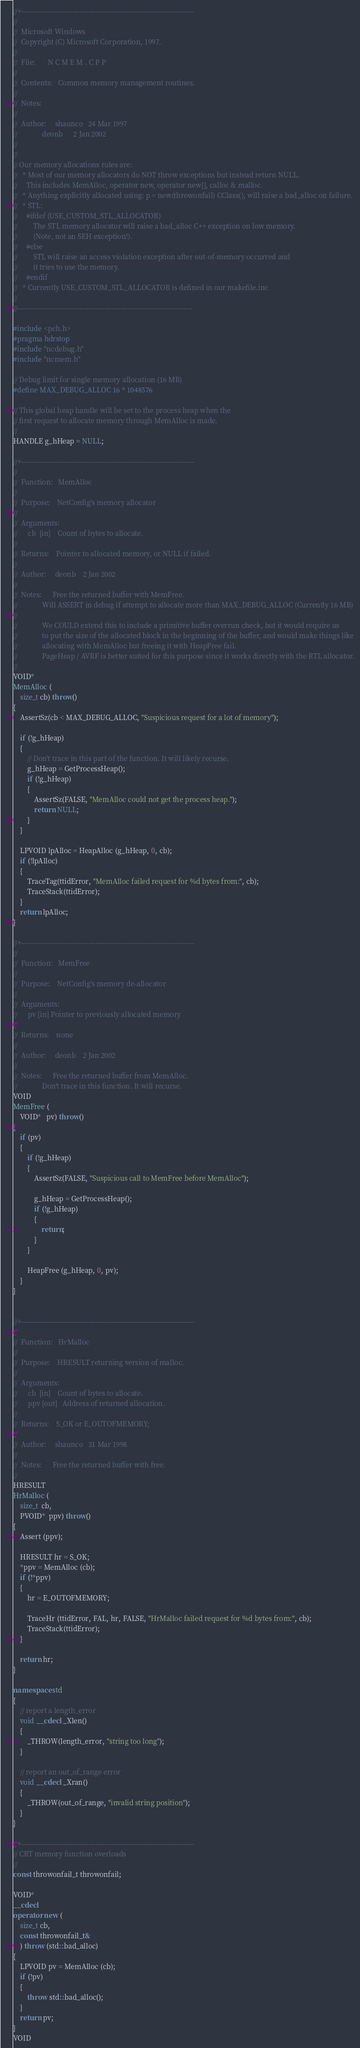Convert code to text. <code><loc_0><loc_0><loc_500><loc_500><_C++_>//+---------------------------------------------------------------------------
//
//  Microsoft Windows
//  Copyright (C) Microsoft Corporation, 1997.
//
//  File:       N C M E M . C P P
//
//  Contents:   Common memory management routines.
//
//  Notes:
//
//  Author:     shaunco   24 Mar 1997
//              deonb      2 Jan 2002
//
//
// Our memory allocations rules are:
//   * Most of our memory allocators do NOT throw exceptions but instead return NULL. 
//     This includes MemAlloc, operator new, operator new[], calloc & malloc.
//   * Anything explicitly allocated using: p = new(throwonfail) CClass(), will raise a bad_alloc on failure.
//   * STL:
//     #ifdef (USE_CUSTOM_STL_ALLOCATOR)
//         The STL memory allocator will raise a bad_alloc C++ exception on low memory.
//         (Note, not an SEH exception!). 
//     #else
//         STL will raise an access violation exception after out-of-memory occurred and
//         it tries to use the memory.
//     #endif
//   * Currently USE_CUSTOM_STL_ALLOCATOR is defined in our makefile.inc
// 
//----------------------------------------------------------------------------

#include <pch.h>
#pragma hdrstop
#include "ncdebug.h"
#include "ncmem.h"

// Debug limit for single memory allocation (16 MB)
#define MAX_DEBUG_ALLOC 16 * 1048576

// This global heap handle will be set to the process heap when the
// first request to allocate memory through MemAlloc is made.
//
HANDLE g_hHeap = NULL;

//+---------------------------------------------------------------------------
//
//  Function:   MemAlloc
//
//  Purpose:    NetConfig's memory allocator
//
//  Arguments:
//      cb  [in]    Count of bytes to allocate.
//
//  Returns:    Pointer to allocated memory, or NULL if failed.
//
//  Author:     deonb    2 Jan 2002
//
//  Notes:      Free the returned buffer with MemFree.
//              Will ASSERT in debug if attempt to allocate more than MAX_DEBUG_ALLOC (Currently 16 MB)
//
//              We COULD extend this to include a primitive buffer overrun check, but it would require us
//              to put the size of the allocated block in the beginning of the buffer, and would make things like
//              allocating with MemAlloc but freeing it with HeapFree fail. 
//              PageHeap / AVRF is better suited for this purpose since it works directly with the RTL allocator.
//
VOID*
MemAlloc (
    size_t cb) throw()
{
    AssertSz(cb < MAX_DEBUG_ALLOC, "Suspicious request for a lot of memory"); 

    if (!g_hHeap)
    {
        // Don't trace in this part of the function. It will likely recurse.
        g_hHeap = GetProcessHeap();
        if (!g_hHeap)
        {
            AssertSz(FALSE, "MemAlloc could not get the process heap.");
            return NULL;
        }
    }

    LPVOID lpAlloc = HeapAlloc (g_hHeap, 0, cb);
    if (!lpAlloc)
    {
        TraceTag(ttidError, "MemAlloc failed request for %d bytes from:", cb);
        TraceStack(ttidError);
    }
    return lpAlloc;
}

//+---------------------------------------------------------------------------
//
//  Function:   MemFree
//
//  Purpose:    NetConfig's memory de-allocator
//
//  Arguments:
//      pv [in] Pointer to previously allocated memory
//
//  Returns:    none
//
//  Author:     deonb    2 Jan 2002
//
//  Notes:      Free the returned buffer from MemAlloc.
//              Don't trace in this function. It will recurse.
VOID
MemFree (
    VOID*   pv) throw()
{
    if (pv) 
    {
        if (!g_hHeap)
        {
            AssertSz(FALSE, "Suspicious call to MemFree before MemAlloc");

            g_hHeap = GetProcessHeap();
            if (!g_hHeap)
            {
                return;
            }
        }

        HeapFree (g_hHeap, 0, pv);
    }
}


//+---------------------------------------------------------------------------
//
//  Function:   HrMalloc
//
//  Purpose:    HRESULT returning version of malloc.
//
//  Arguments:
//      cb  [in]    Count of bytes to allocate.
//      ppv [out]   Address of returned allocation.
//
//  Returns:    S_OK or E_OUTOFMEMORY;
//
//  Author:     shaunco   31 Mar 1998
//
//  Notes:      Free the returned buffer with free.
//
HRESULT
HrMalloc (
    size_t  cb,
    PVOID*  ppv) throw()
{
    Assert (ppv);

    HRESULT hr = S_OK;
    *ppv = MemAlloc (cb);
    if (!*ppv)
    {
        hr = E_OUTOFMEMORY;
    
        TraceHr (ttidError, FAL, hr, FALSE, "HrMalloc failed request for %d bytes from:", cb);
        TraceStack(ttidError);
    }

    return hr;
}

namespace std
{
    // report a length_error
    void __cdecl _Xlen()
    {
        _THROW(length_error, "string too long"); 
    }

	// report an out_of_range error
    void __cdecl _Xran()
    {
        _THROW(out_of_range, "invalid string position"); 
    }
}

//+---------------------------------------------------------------------------
// CRT memory function overloads
//
const throwonfail_t throwonfail;

VOID*
__cdecl
operator new (
    size_t cb,
    const throwonfail_t&
    ) throw (std::bad_alloc)
{
    LPVOID pv = MemAlloc (cb);
    if (!pv)
    {
        throw std::bad_alloc();
    }
    return pv;
}
VOID</code> 